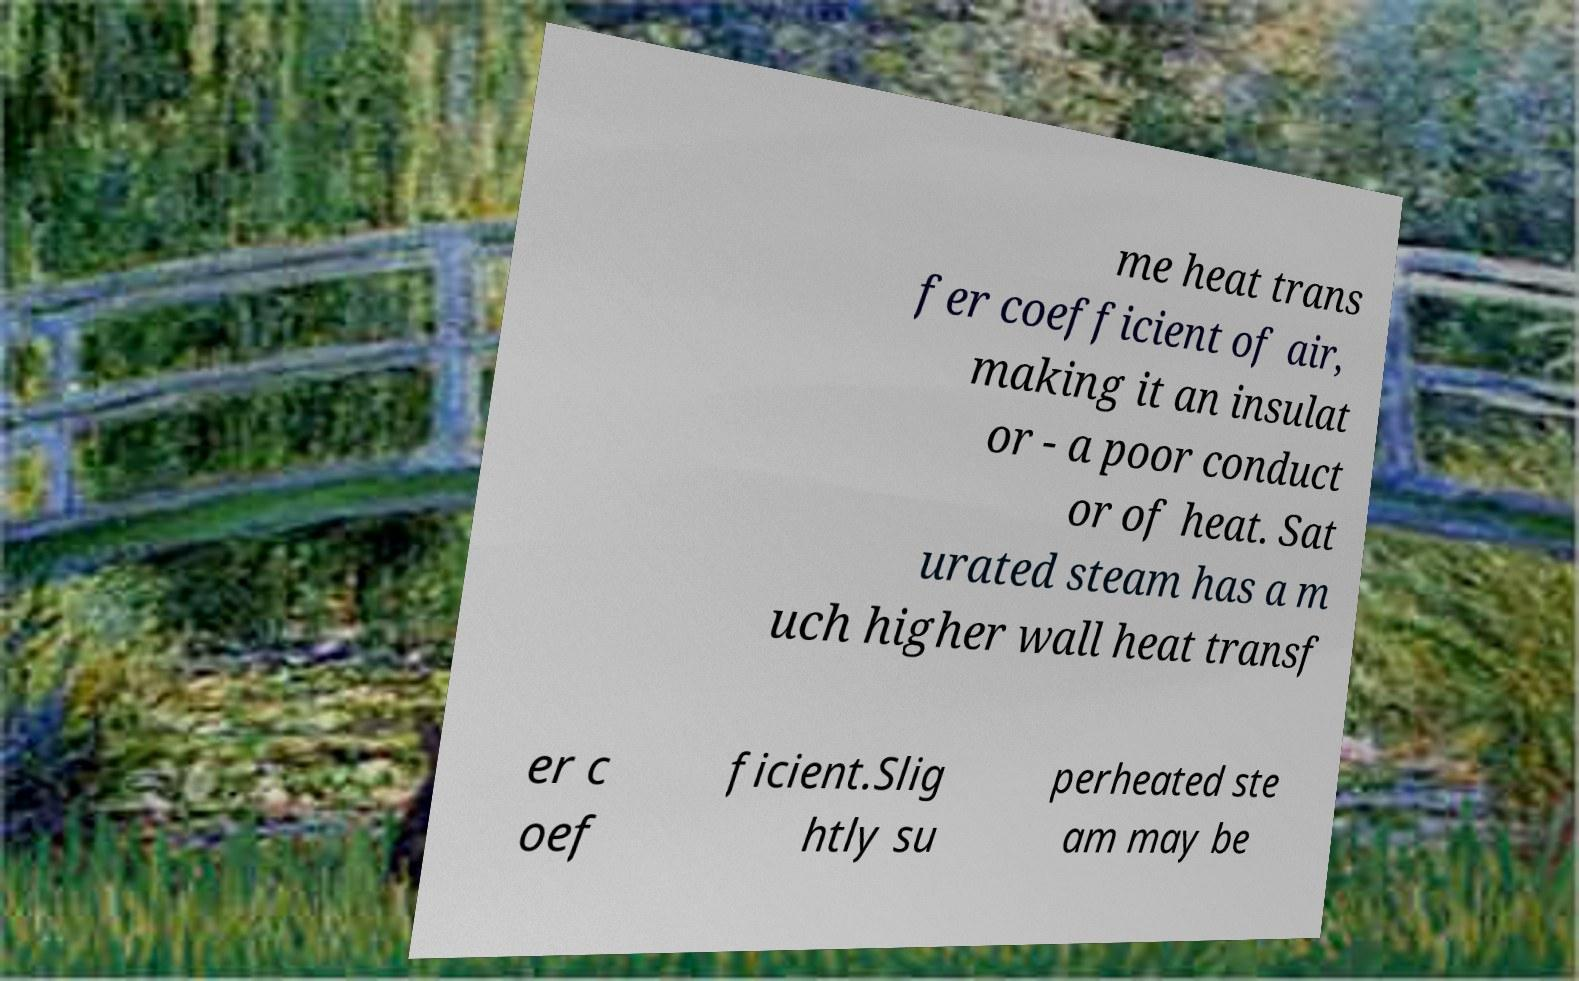What messages or text are displayed in this image? I need them in a readable, typed format. me heat trans fer coefficient of air, making it an insulat or - a poor conduct or of heat. Sat urated steam has a m uch higher wall heat transf er c oef ficient.Slig htly su perheated ste am may be 